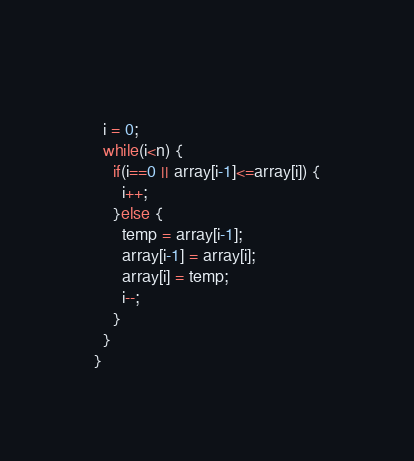<code> <loc_0><loc_0><loc_500><loc_500><_C_>  
  i = 0;
  while(i<n) {
    if(i==0 || array[i-1]<=array[i]) {
      i++;
    }else {
      temp = array[i-1];
      array[i-1] = array[i];
      array[i] = temp;
      i--;
    }    
  }  
}</code> 